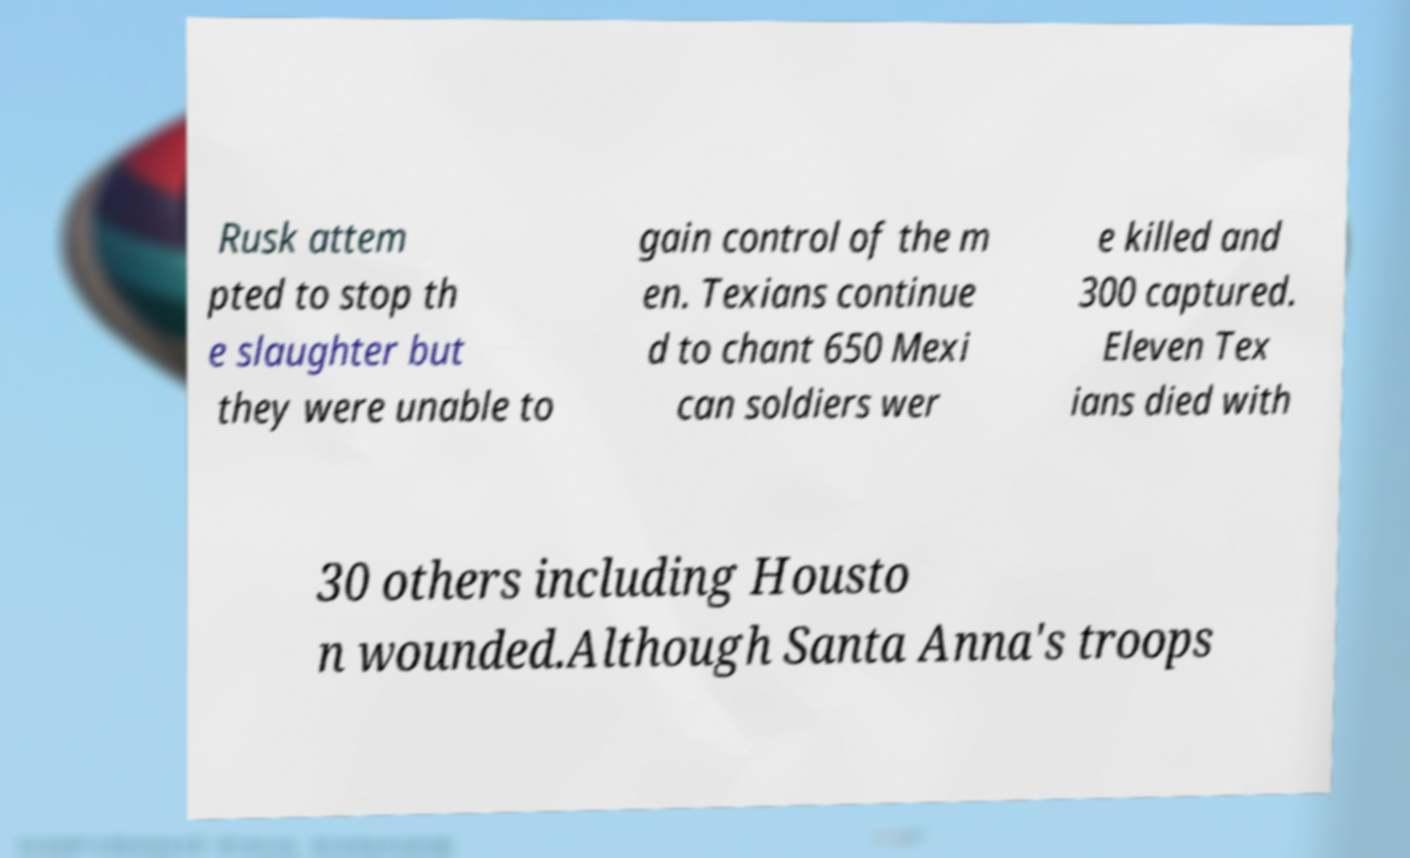Please identify and transcribe the text found in this image. Rusk attem pted to stop th e slaughter but they were unable to gain control of the m en. Texians continue d to chant 650 Mexi can soldiers wer e killed and 300 captured. Eleven Tex ians died with 30 others including Housto n wounded.Although Santa Anna's troops 